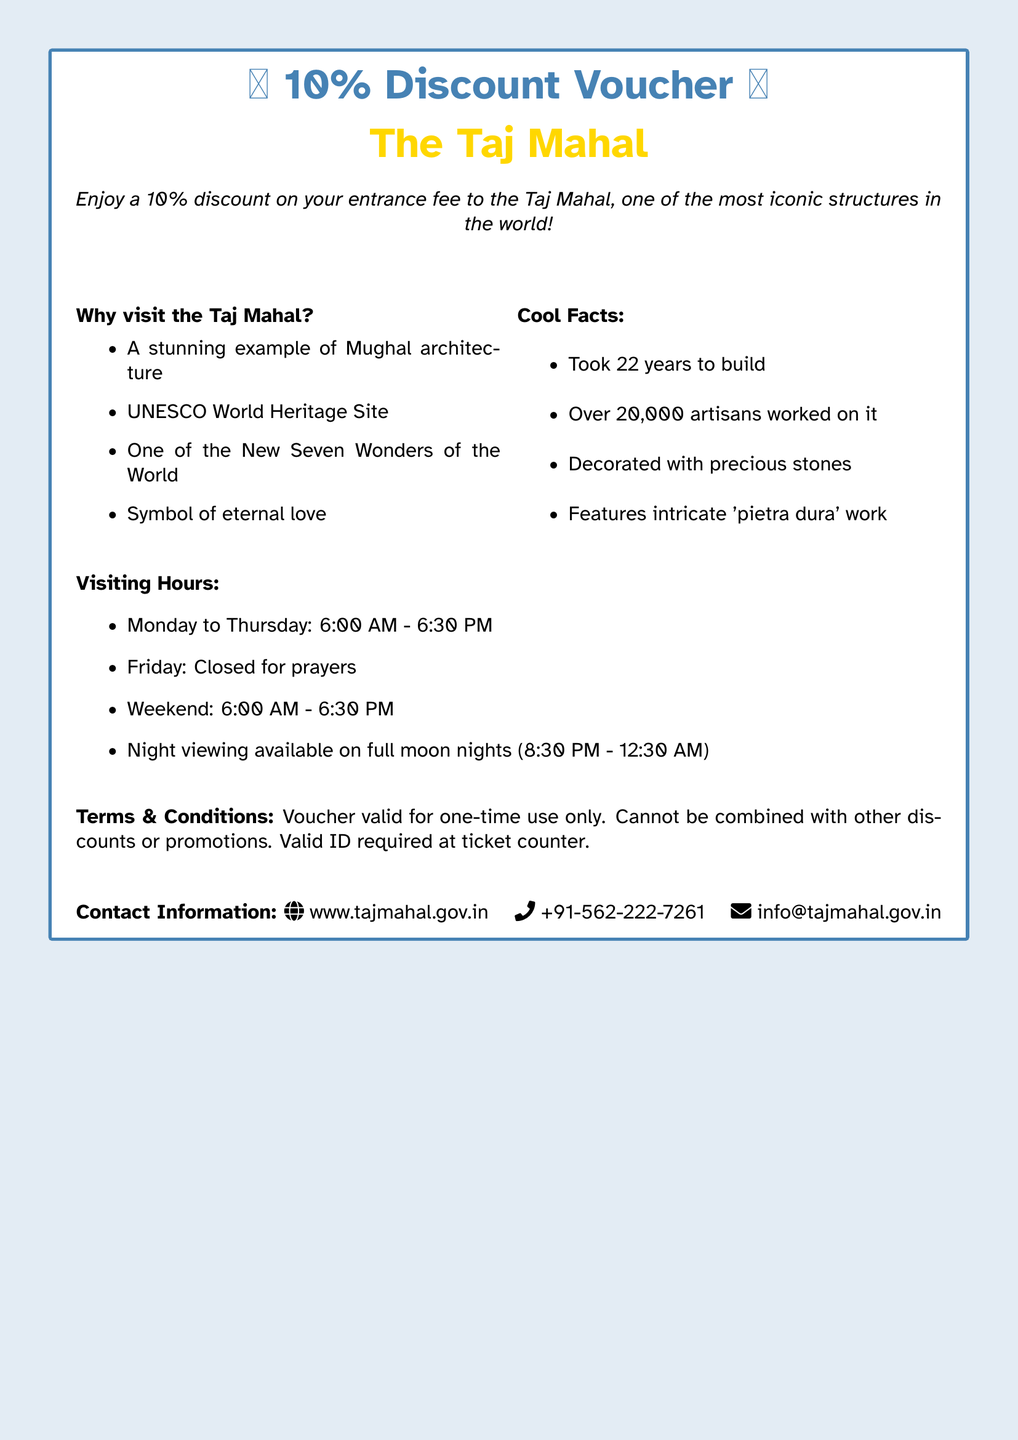What is the discount offered on the voucher? The voucher provides a discount of 10% on the entrance fee to the Taj Mahal.
Answer: 10% What is the visiting hour on Fridays? According to the document, the Taj Mahal is closed for prayers on Fridays.
Answer: Closed Which architectural style does the Taj Mahal represent? The document states that the Taj Mahal is a stunning example of Mughal architecture.
Answer: Mughal architecture How long did it take to build the Taj Mahal? The document mentions that it took 22 years to build the Taj Mahal.
Answer: 22 years What significant marks the Taj Mahal as a UNESCO site? The document refers to the Taj Mahal as a UNESCO World Heritage Site, highlighting its global importance.
Answer: UNESCO World Heritage Site What unique viewing opportunity is mentioned? The document notes that there is night viewing available on full moon nights, enhancing the experience of visiting the monument.
Answer: Night viewing Is the voucher valid for multiple uses? The document states that the voucher is valid for one-time use only, indicating limitations on its usage.
Answer: One-time use only What is the contact website for the Taj Mahal? The document provides the official website as the contact information for inquiries related to the Taj Mahal.
Answer: www.tajmahal.gov.in What does the Taj Mahal symbolize? The document indicates that the Taj Mahal is a symbol of eternal love, reflecting its cultural significance.
Answer: Symbol of eternal love 